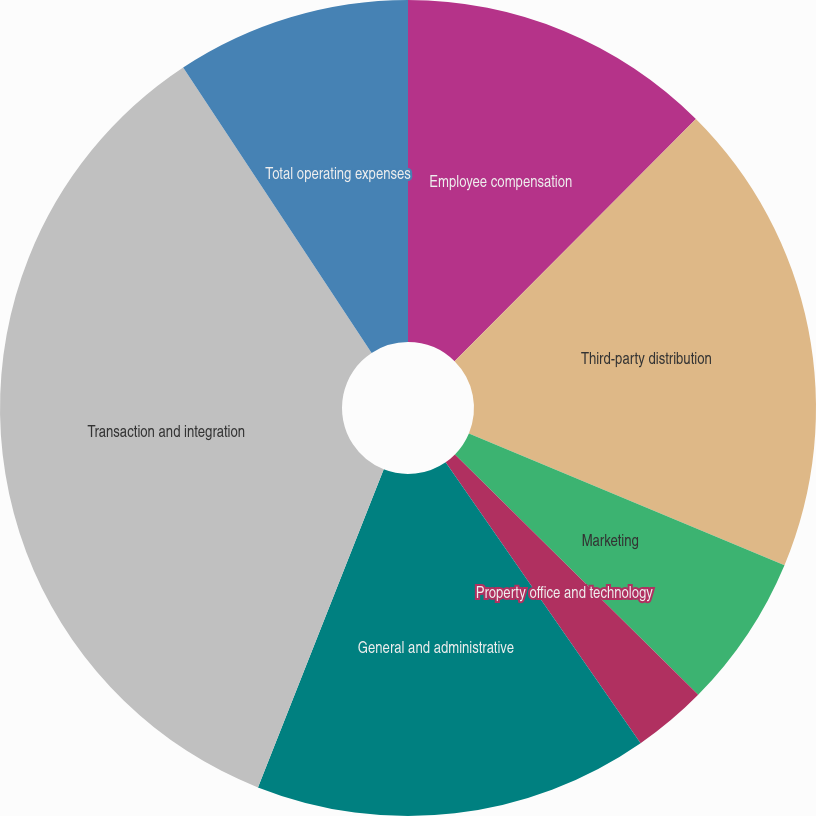Convert chart. <chart><loc_0><loc_0><loc_500><loc_500><pie_chart><fcel>Employee compensation<fcel>Third-party distribution<fcel>Marketing<fcel>Property office and technology<fcel>General and administrative<fcel>Transaction and integration<fcel>Total operating expenses<nl><fcel>12.47%<fcel>18.83%<fcel>6.11%<fcel>2.94%<fcel>15.65%<fcel>34.72%<fcel>9.29%<nl></chart> 